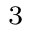<formula> <loc_0><loc_0><loc_500><loc_500>_ { 3 }</formula> 